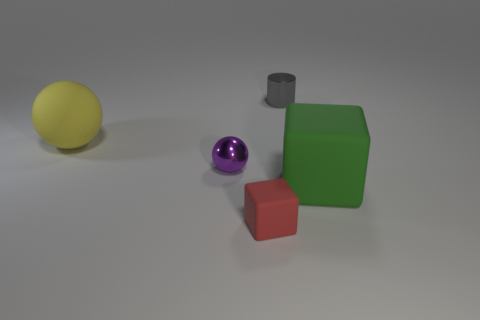How many things are either small shiny objects that are left of the small metal cylinder or gray balls?
Make the answer very short. 1. Is the number of tiny purple things that are behind the large yellow object the same as the number of big balls?
Make the answer very short. No. What color is the object that is both behind the small purple object and right of the large rubber sphere?
Keep it short and to the point. Gray. What number of balls are either large red objects or red objects?
Offer a very short reply. 0. Is the number of tiny gray shiny cylinders to the left of the red block less than the number of gray metal objects?
Provide a short and direct response. Yes. What is the shape of the red thing that is the same material as the green cube?
Provide a short and direct response. Cube. What number of small cylinders have the same color as the rubber sphere?
Offer a very short reply. 0. How many objects are big brown rubber cubes or metal spheres?
Make the answer very short. 1. There is a tiny object that is behind the small metal object that is in front of the small gray object; what is its material?
Offer a very short reply. Metal. Are there any tiny purple spheres made of the same material as the tiny gray object?
Offer a very short reply. Yes. 